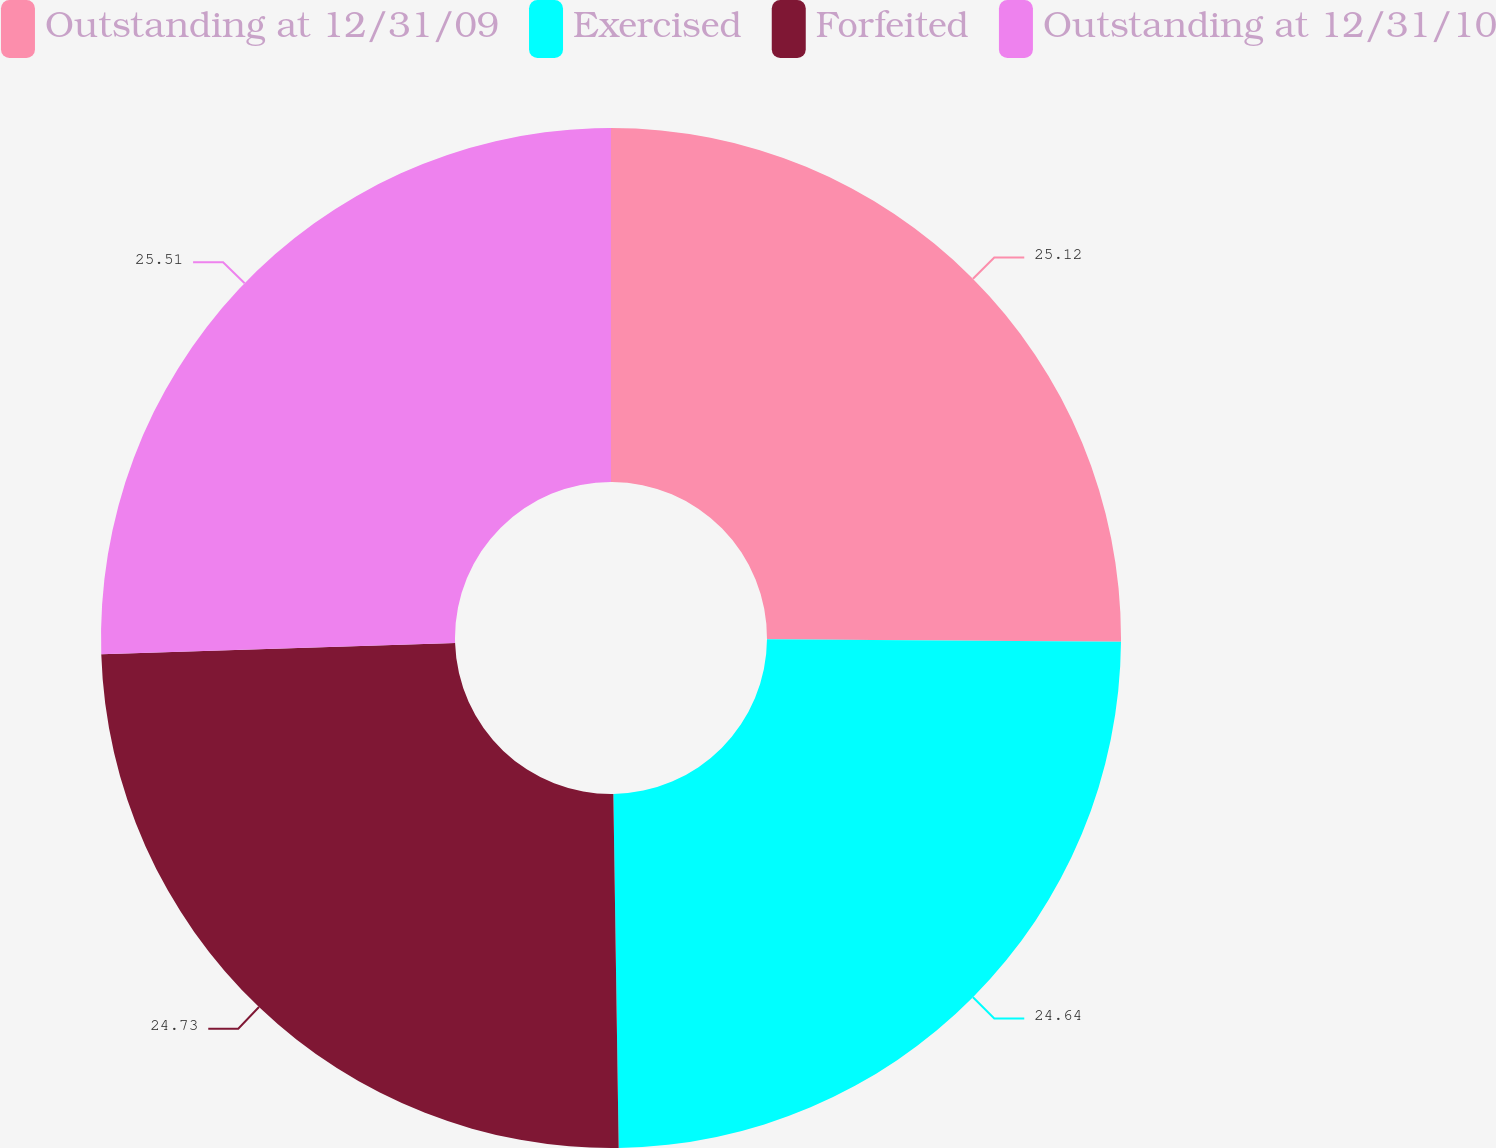Convert chart to OTSL. <chart><loc_0><loc_0><loc_500><loc_500><pie_chart><fcel>Outstanding at 12/31/09<fcel>Exercised<fcel>Forfeited<fcel>Outstanding at 12/31/10<nl><fcel>25.12%<fcel>24.64%<fcel>24.73%<fcel>25.51%<nl></chart> 